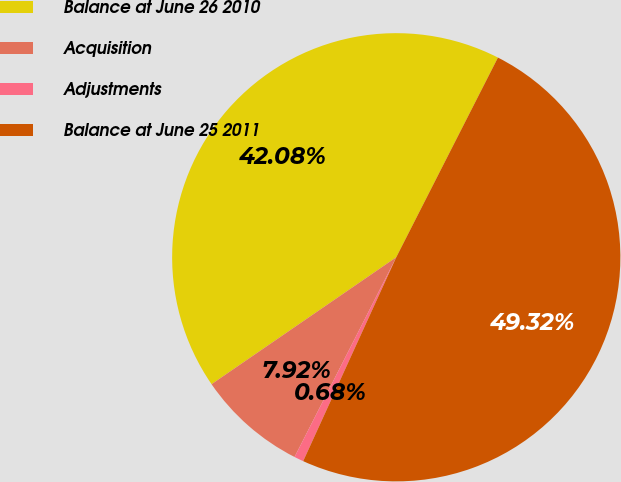Convert chart. <chart><loc_0><loc_0><loc_500><loc_500><pie_chart><fcel>Balance at June 26 2010<fcel>Acquisition<fcel>Adjustments<fcel>Balance at June 25 2011<nl><fcel>42.08%<fcel>7.92%<fcel>0.68%<fcel>49.32%<nl></chart> 